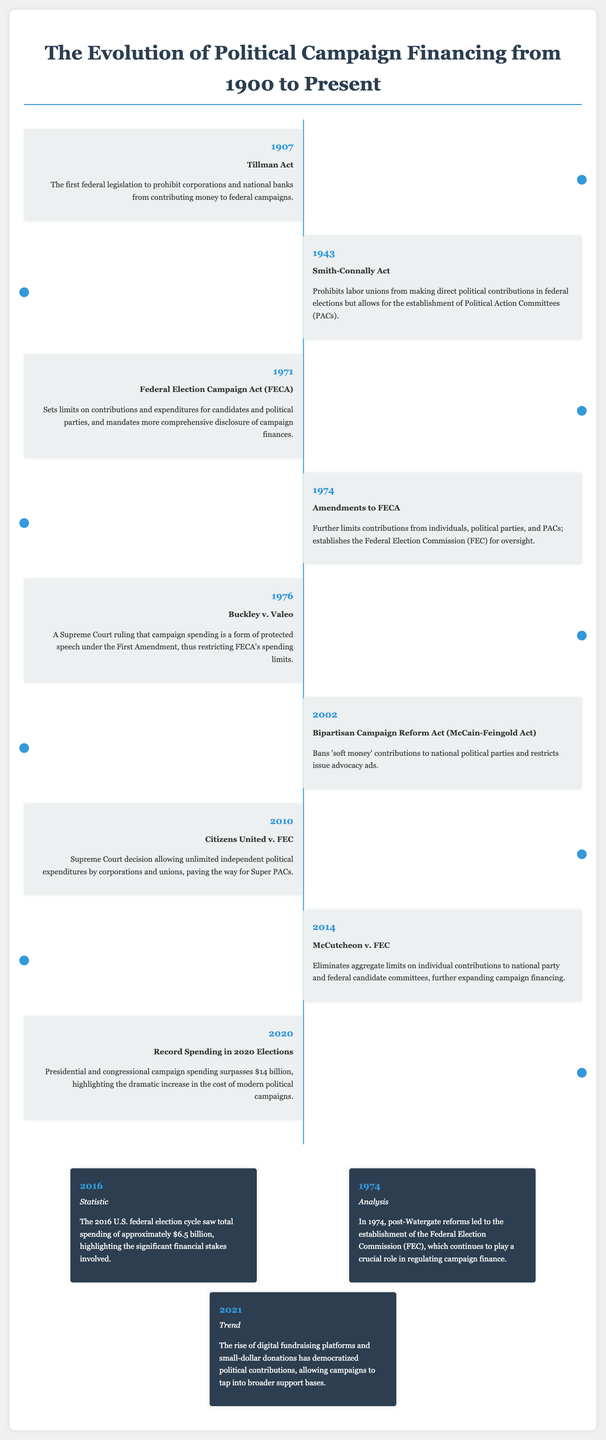What year was the Tillman Act enacted? The Tillman Act, which prohibited corporations and national banks from contributing money to federal campaigns, was enacted in 1907.
Answer: 1907 What is the main outcome of Buckley v. Valeo? Buckley v. Valeo resulted in a Supreme Court ruling that recognized campaign spending as protected speech under the First Amendment, affecting FECA's spending limits.
Answer: Protected speech What legislation established the Federal Election Commission? The Federal Election Commission (FEC) was established as part of the amendments to the Federal Election Campaign Act (FECA) in 1974.
Answer: FECA Which act banned 'soft money' contributions? The Bipartisan Campaign Reform Act, also known as the McCain-Feingold Act, banned 'soft money' contributions to national political parties.
Answer: McCain-Feingold Act How much was spent in the 2016 U.S. federal election cycle? The total spending in the 2016 U.S. federal election cycle was approximately $6.5 billion.
Answer: $6.5 billion What significant change occurred in 2021 regarding political contributions? In 2021, the rise of digital fundraising platforms democratized political contributions, allowing campaigns to tap into broader support bases.
Answer: Digital fundraising What was the record spending in the 2020 elections? Total campaign spending in the 2020 elections surpassed $14 billion, indicating a dramatic increase in campaign costs.
Answer: $14 billion What year did Citizens United v. FEC occur? Citizens United v. FEC was a significant Supreme Court decision that occurred in 2010.
Answer: 2010 In what year was the Smith-Connally Act passed? The Smith-Connally Act, which prohibits labor unions from making direct political contributions in federal elections, was passed in 1943.
Answer: 1943 